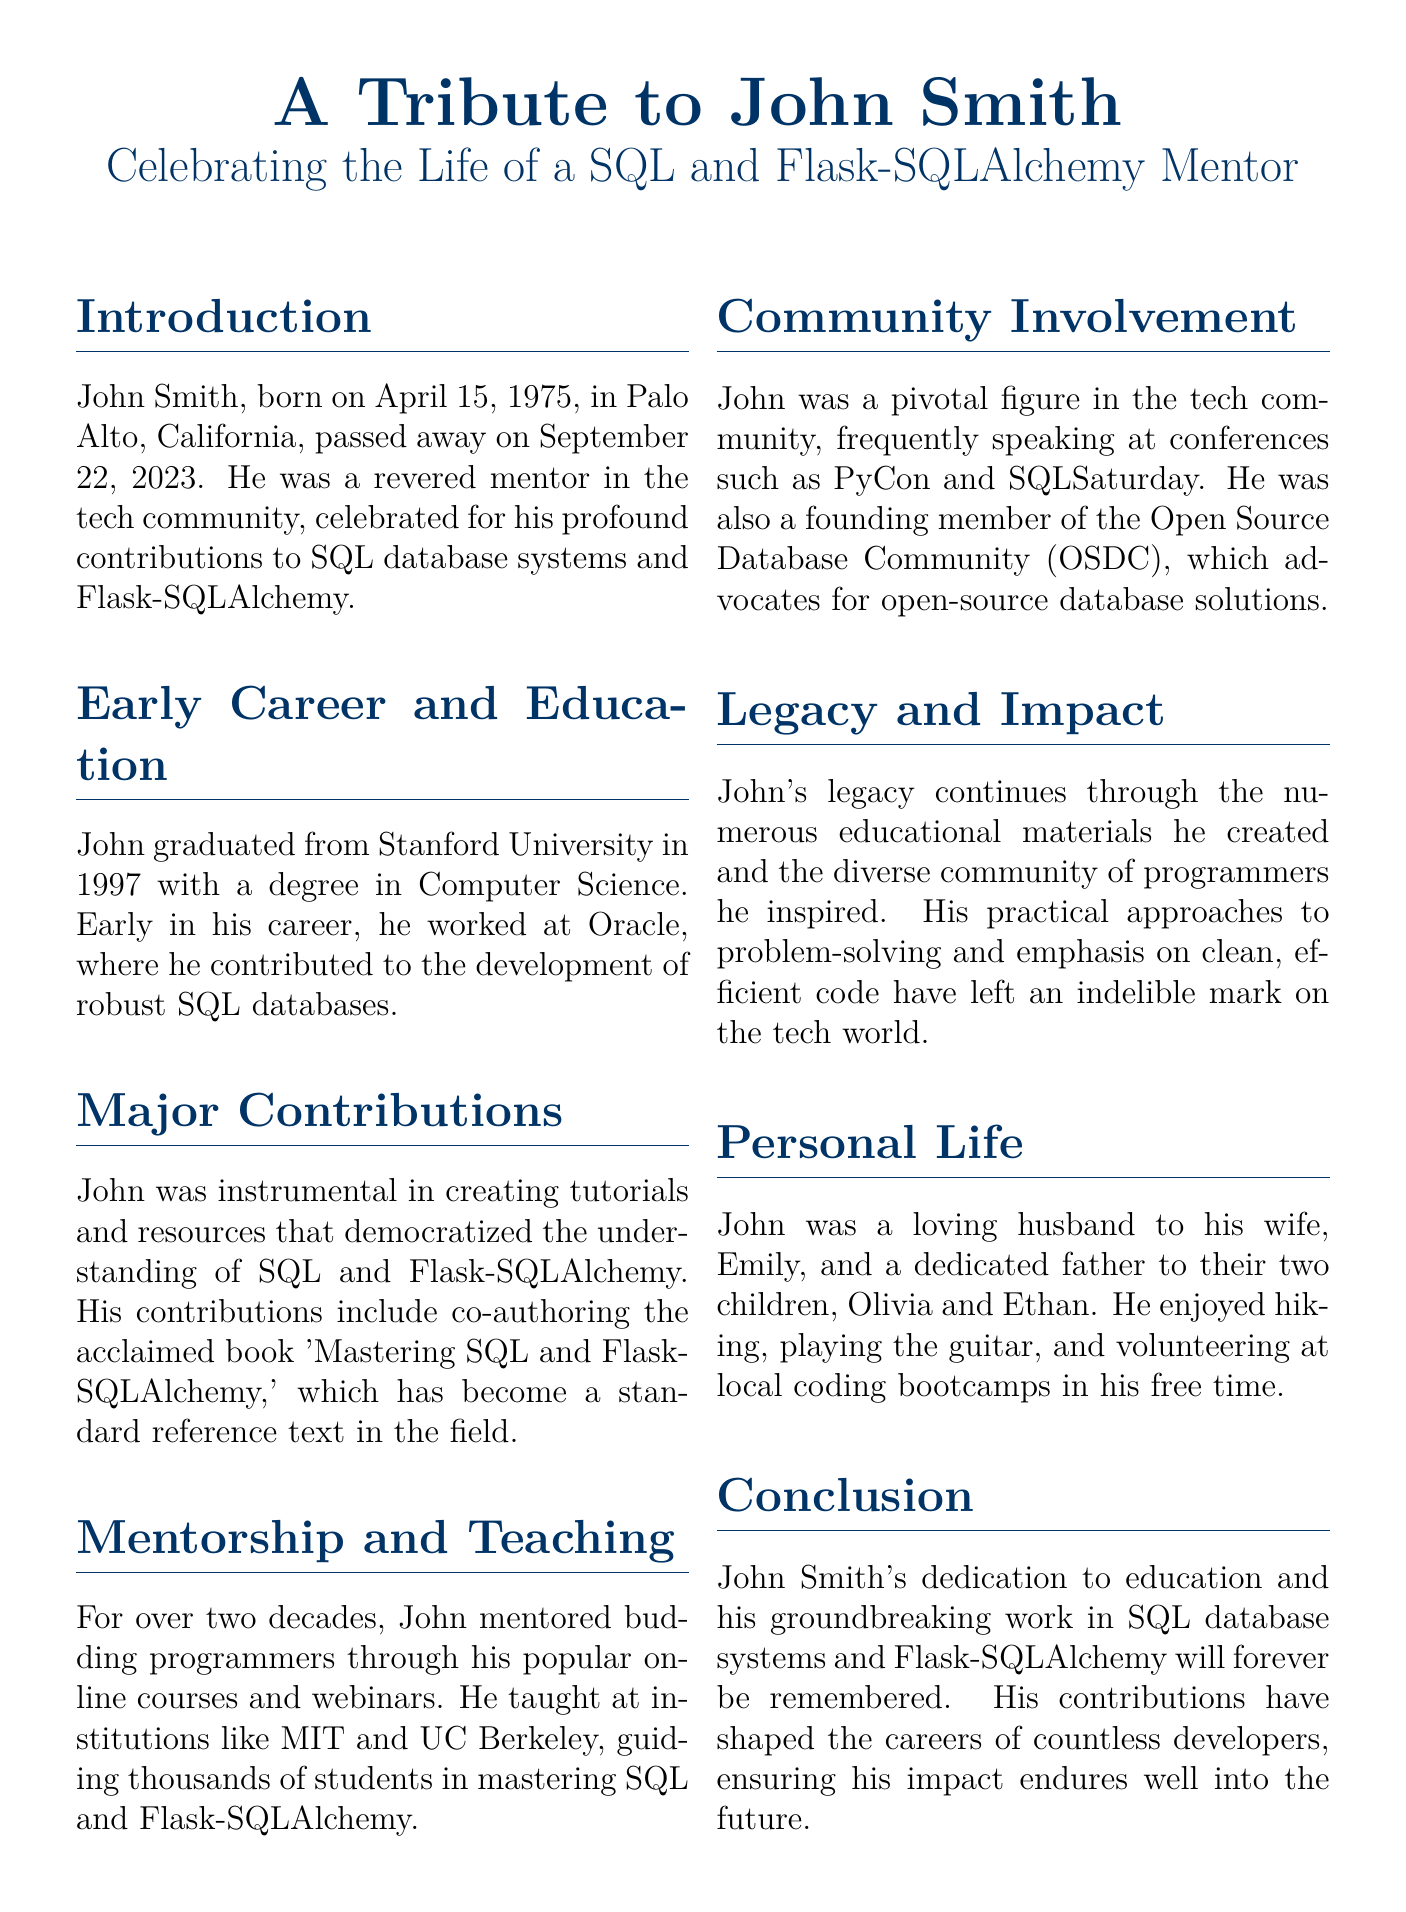What date was John Smith born? John Smith was born on April 15, 1975, as stated in the introduction.
Answer: April 15, 1975 Which university did John graduate from? The document states that John graduated from Stanford University in 1997.
Answer: Stanford University What book did John co-author? The document mentions that he co-authored 'Mastering SQL and Flask-SQLAlchemy.'
Answer: Mastering SQL and Flask-SQLAlchemy How many children did John have? The document indicates that he had two children, Olivia and Ethan.
Answer: Two What role did John have at Oracle? The document specifies that he worked on the development of robust SQL databases at Oracle.
Answer: Development of robust SQL databases Which prestigious conferences did John speak at? The document lists PyCon and SQLSaturday as conferences where he frequently spoke.
Answer: PyCon and SQLSaturday What was a key aspect of John's teaching approach? The document highlights John's emphasis on clean, efficient code in his teaching.
Answer: Clean, efficient code What year did John pass away? The document states that John passed away on September 22, 2023.
Answer: September 22, 2023 Who was John’s wife? The document provides the name of John’s wife as Emily.
Answer: Emily 